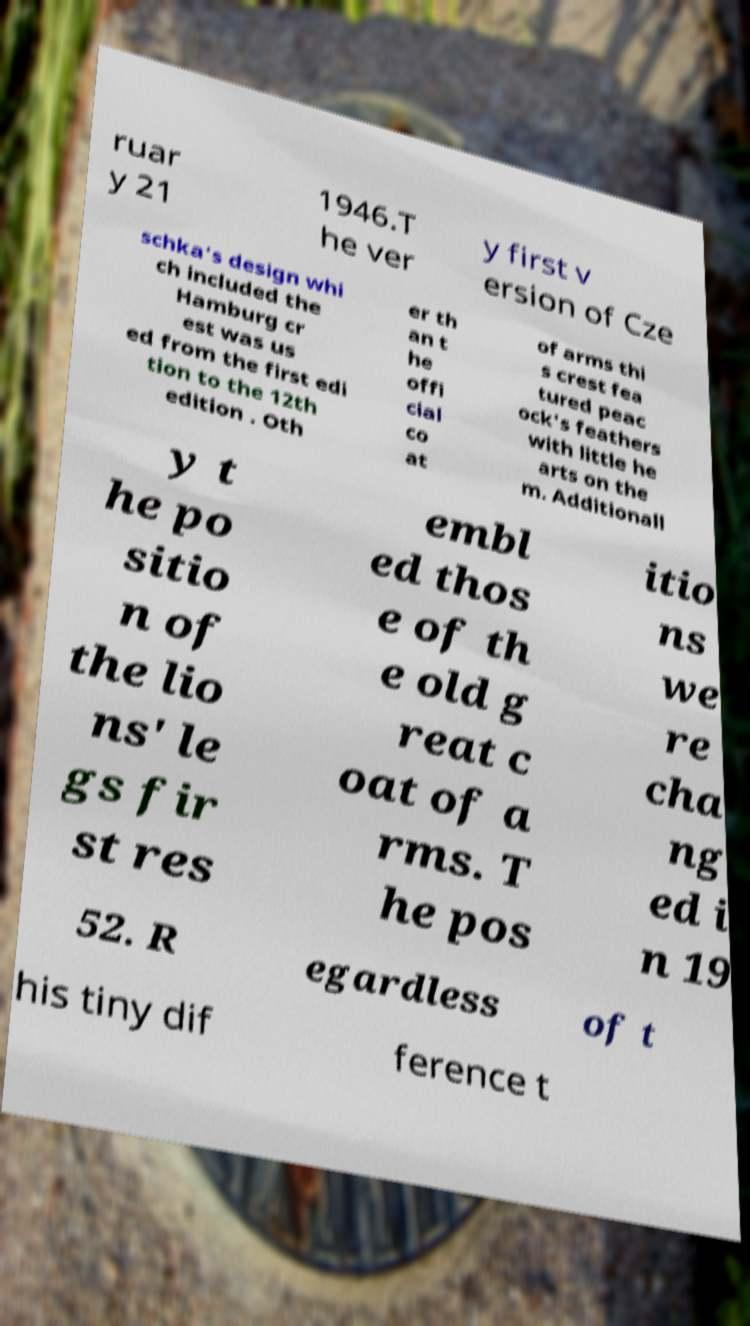Could you assist in decoding the text presented in this image and type it out clearly? ruar y 21 1946.T he ver y first v ersion of Cze schka's design whi ch included the Hamburg cr est was us ed from the first edi tion to the 12th edition . Oth er th an t he offi cial co at of arms thi s crest fea tured peac ock's feathers with little he arts on the m. Additionall y t he po sitio n of the lio ns' le gs fir st res embl ed thos e of th e old g reat c oat of a rms. T he pos itio ns we re cha ng ed i n 19 52. R egardless of t his tiny dif ference t 